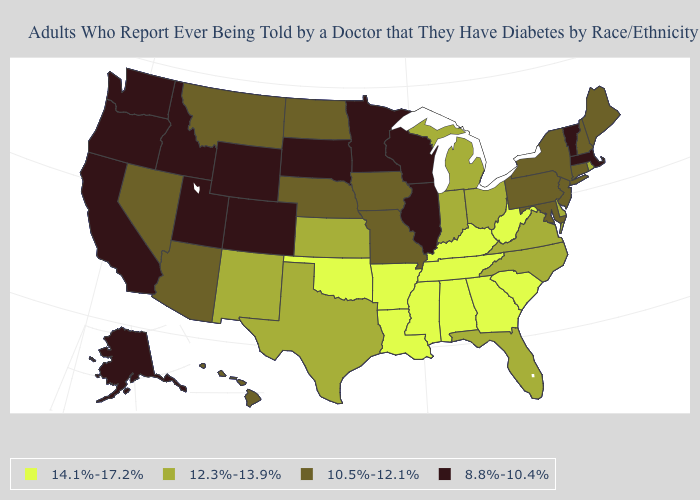Among the states that border Alabama , which have the highest value?
Give a very brief answer. Georgia, Mississippi, Tennessee. Which states have the highest value in the USA?
Be succinct. Alabama, Arkansas, Georgia, Kentucky, Louisiana, Mississippi, Oklahoma, South Carolina, Tennessee, West Virginia. What is the value of New Jersey?
Concise answer only. 10.5%-12.1%. Does Rhode Island have the same value as Florida?
Be succinct. Yes. Among the states that border Massachusetts , does Vermont have the lowest value?
Short answer required. Yes. What is the value of Virginia?
Concise answer only. 12.3%-13.9%. Name the states that have a value in the range 8.8%-10.4%?
Short answer required. Alaska, California, Colorado, Idaho, Illinois, Massachusetts, Minnesota, Oregon, South Dakota, Utah, Vermont, Washington, Wisconsin, Wyoming. Among the states that border Iowa , does South Dakota have the highest value?
Keep it brief. No. Name the states that have a value in the range 8.8%-10.4%?
Be succinct. Alaska, California, Colorado, Idaho, Illinois, Massachusetts, Minnesota, Oregon, South Dakota, Utah, Vermont, Washington, Wisconsin, Wyoming. Does the first symbol in the legend represent the smallest category?
Answer briefly. No. Which states have the lowest value in the Northeast?
Keep it brief. Massachusetts, Vermont. Name the states that have a value in the range 14.1%-17.2%?
Short answer required. Alabama, Arkansas, Georgia, Kentucky, Louisiana, Mississippi, Oklahoma, South Carolina, Tennessee, West Virginia. Does the first symbol in the legend represent the smallest category?
Quick response, please. No. Name the states that have a value in the range 12.3%-13.9%?
Give a very brief answer. Delaware, Florida, Indiana, Kansas, Michigan, New Mexico, North Carolina, Ohio, Rhode Island, Texas, Virginia. What is the highest value in the West ?
Be succinct. 12.3%-13.9%. 